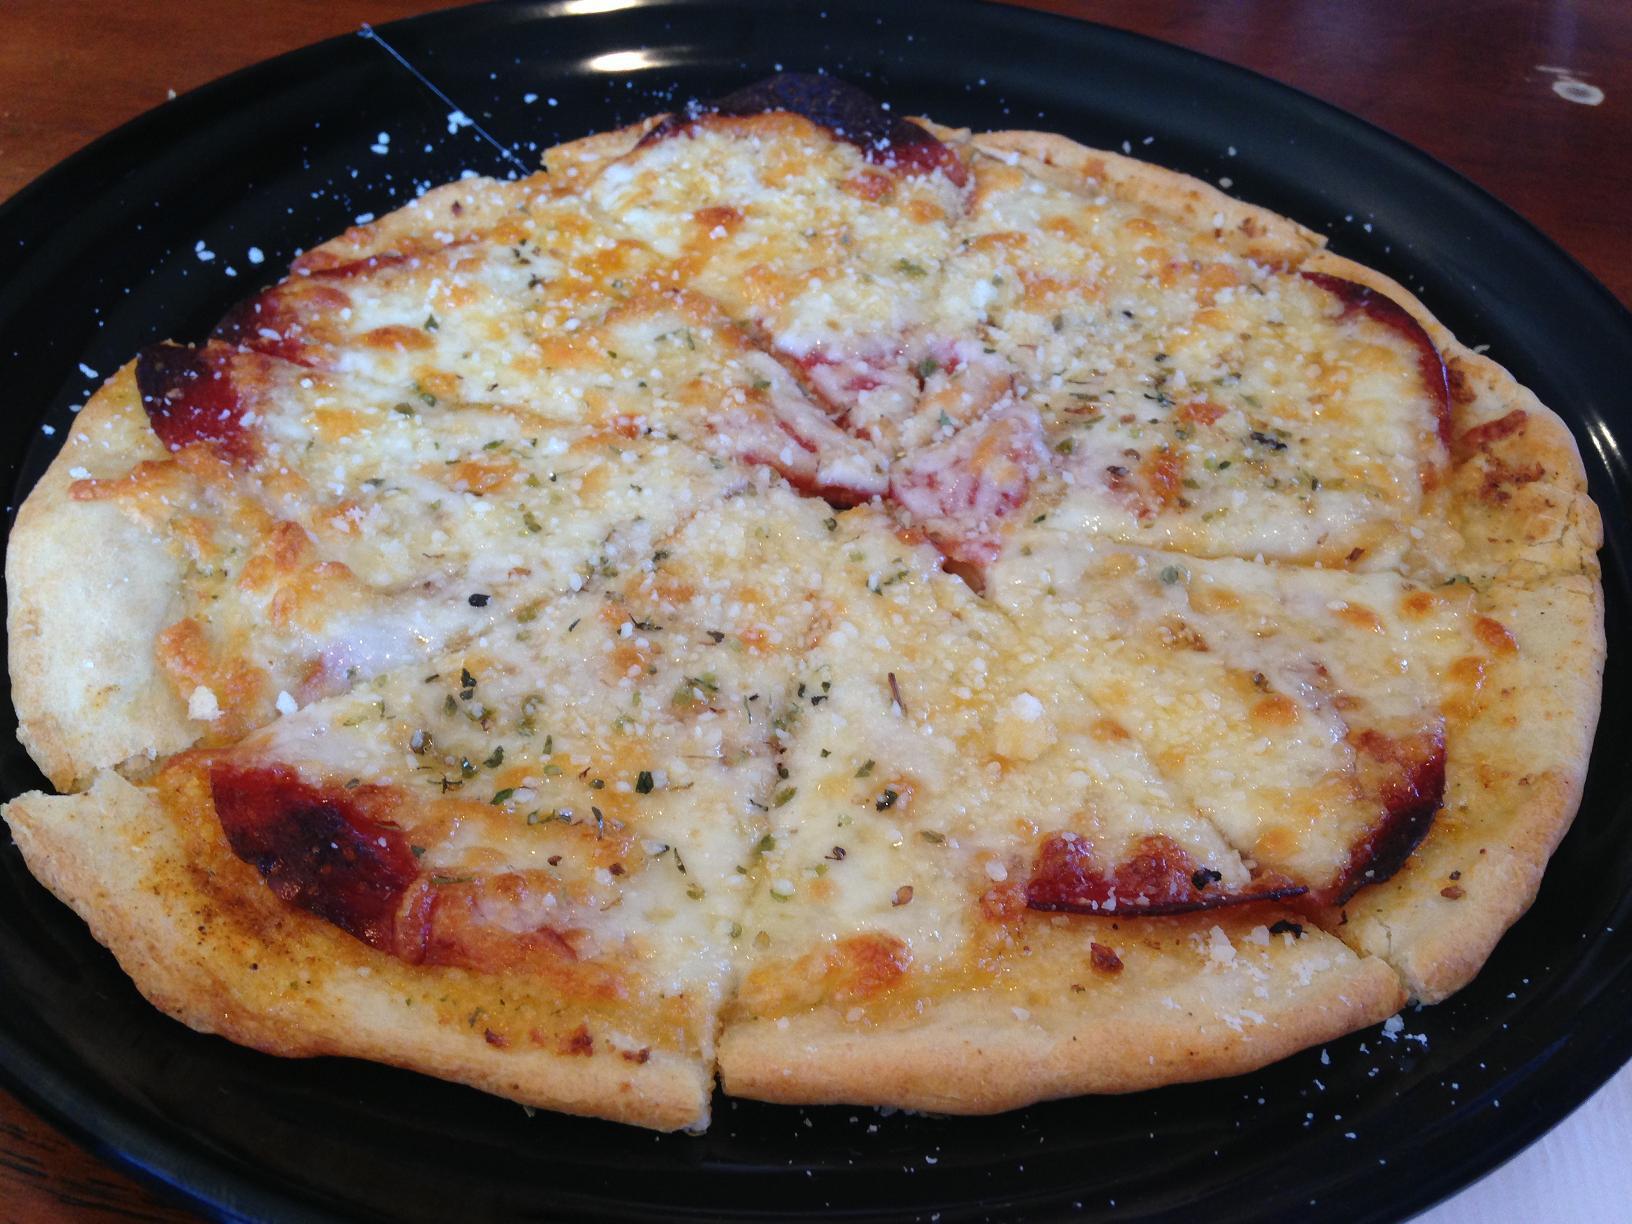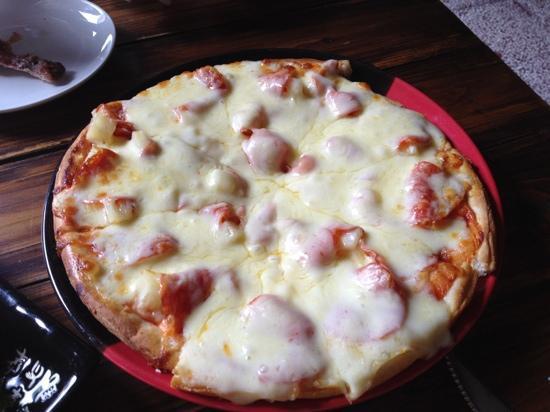The first image is the image on the left, the second image is the image on the right. Evaluate the accuracy of this statement regarding the images: "The pizza on the left has citrus on top.". Is it true? Answer yes or no. No. The first image is the image on the left, the second image is the image on the right. For the images shown, is this caption "There is at least one lemon on top of the pizza." true? Answer yes or no. No. 